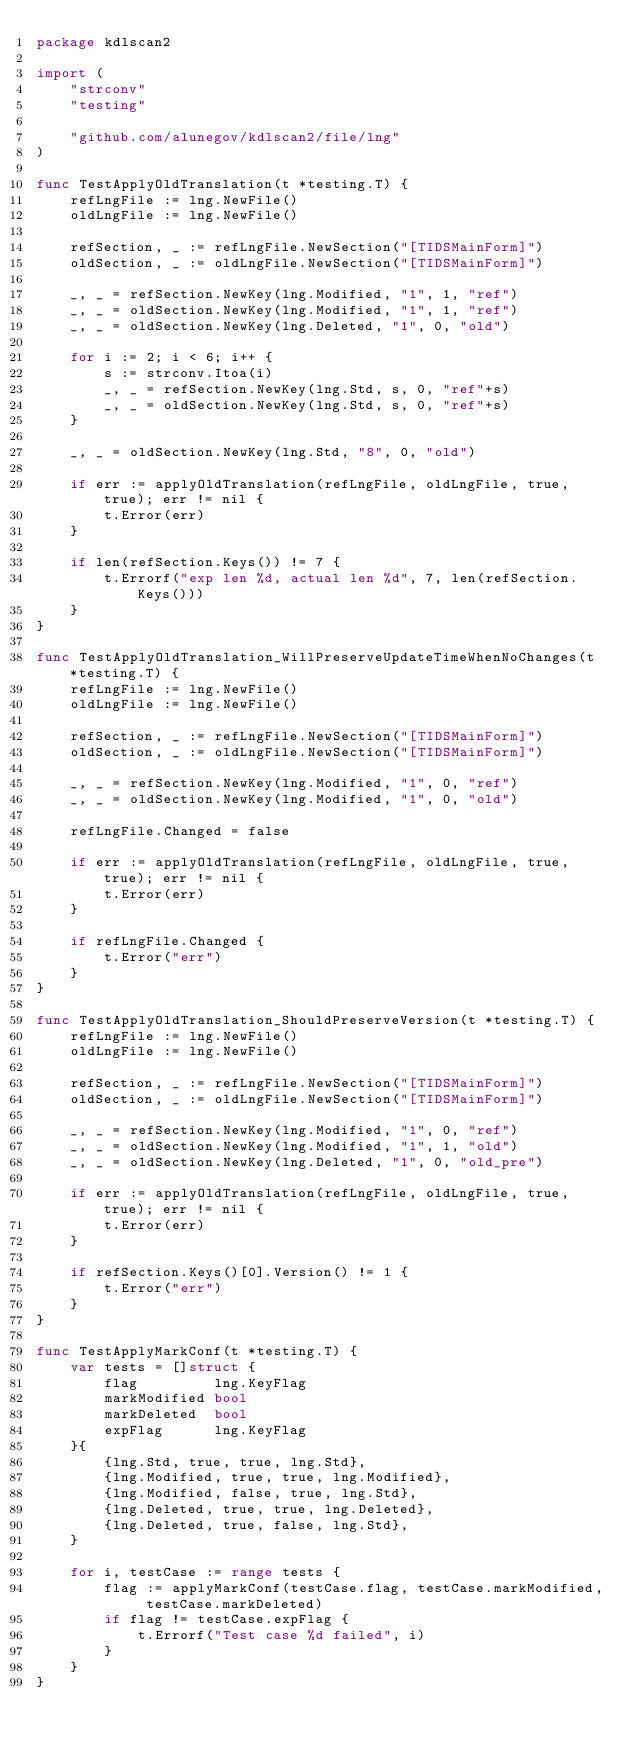Convert code to text. <code><loc_0><loc_0><loc_500><loc_500><_Go_>package kdlscan2

import (
	"strconv"
	"testing"

	"github.com/alunegov/kdlscan2/file/lng"
)

func TestApplyOldTranslation(t *testing.T) {
	refLngFile := lng.NewFile()
	oldLngFile := lng.NewFile()

	refSection, _ := refLngFile.NewSection("[TIDSMainForm]")
	oldSection, _ := oldLngFile.NewSection("[TIDSMainForm]")

	_, _ = refSection.NewKey(lng.Modified, "1", 1, "ref")
	_, _ = oldSection.NewKey(lng.Modified, "1", 1, "ref")
	_, _ = oldSection.NewKey(lng.Deleted, "1", 0, "old")

	for i := 2; i < 6; i++ {
		s := strconv.Itoa(i)
		_, _ = refSection.NewKey(lng.Std, s, 0, "ref"+s)
		_, _ = oldSection.NewKey(lng.Std, s, 0, "ref"+s)
	}

	_, _ = oldSection.NewKey(lng.Std, "8", 0, "old")

	if err := applyOldTranslation(refLngFile, oldLngFile, true, true); err != nil {
		t.Error(err)
	}

	if len(refSection.Keys()) != 7 {
		t.Errorf("exp len %d, actual len %d", 7, len(refSection.Keys()))
	}
}

func TestApplyOldTranslation_WillPreserveUpdateTimeWhenNoChanges(t *testing.T) {
	refLngFile := lng.NewFile()
	oldLngFile := lng.NewFile()

	refSection, _ := refLngFile.NewSection("[TIDSMainForm]")
	oldSection, _ := oldLngFile.NewSection("[TIDSMainForm]")

	_, _ = refSection.NewKey(lng.Modified, "1", 0, "ref")
	_, _ = oldSection.NewKey(lng.Modified, "1", 0, "old")

	refLngFile.Changed = false

	if err := applyOldTranslation(refLngFile, oldLngFile, true, true); err != nil {
		t.Error(err)
	}

	if refLngFile.Changed {
		t.Error("err")
	}
}

func TestApplyOldTranslation_ShouldPreserveVersion(t *testing.T) {
	refLngFile := lng.NewFile()
	oldLngFile := lng.NewFile()

	refSection, _ := refLngFile.NewSection("[TIDSMainForm]")
	oldSection, _ := oldLngFile.NewSection("[TIDSMainForm]")

	_, _ = refSection.NewKey(lng.Modified, "1", 0, "ref")
	_, _ = oldSection.NewKey(lng.Modified, "1", 1, "old")
	_, _ = oldSection.NewKey(lng.Deleted, "1", 0, "old_pre")

	if err := applyOldTranslation(refLngFile, oldLngFile, true, true); err != nil {
		t.Error(err)
	}

	if refSection.Keys()[0].Version() != 1 {
		t.Error("err")
	}
}

func TestApplyMarkConf(t *testing.T) {
	var tests = []struct {
		flag         lng.KeyFlag
		markModified bool
		markDeleted  bool
		expFlag      lng.KeyFlag
	}{
		{lng.Std, true, true, lng.Std},
		{lng.Modified, true, true, lng.Modified},
		{lng.Modified, false, true, lng.Std},
		{lng.Deleted, true, true, lng.Deleted},
		{lng.Deleted, true, false, lng.Std},
	}

	for i, testCase := range tests {
		flag := applyMarkConf(testCase.flag, testCase.markModified, testCase.markDeleted)
		if flag != testCase.expFlag {
			t.Errorf("Test case %d failed", i)
		}
	}
}
</code> 